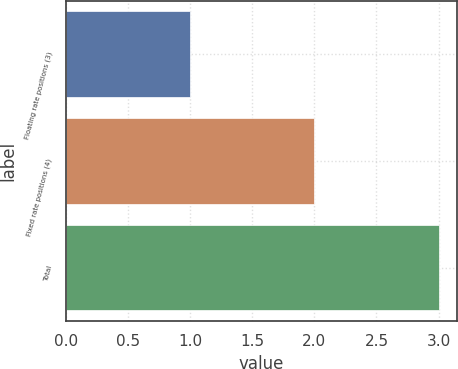Convert chart to OTSL. <chart><loc_0><loc_0><loc_500><loc_500><bar_chart><fcel>Floating rate positions (3)<fcel>Fixed rate positions (4)<fcel>Total<nl><fcel>1<fcel>2<fcel>3<nl></chart> 